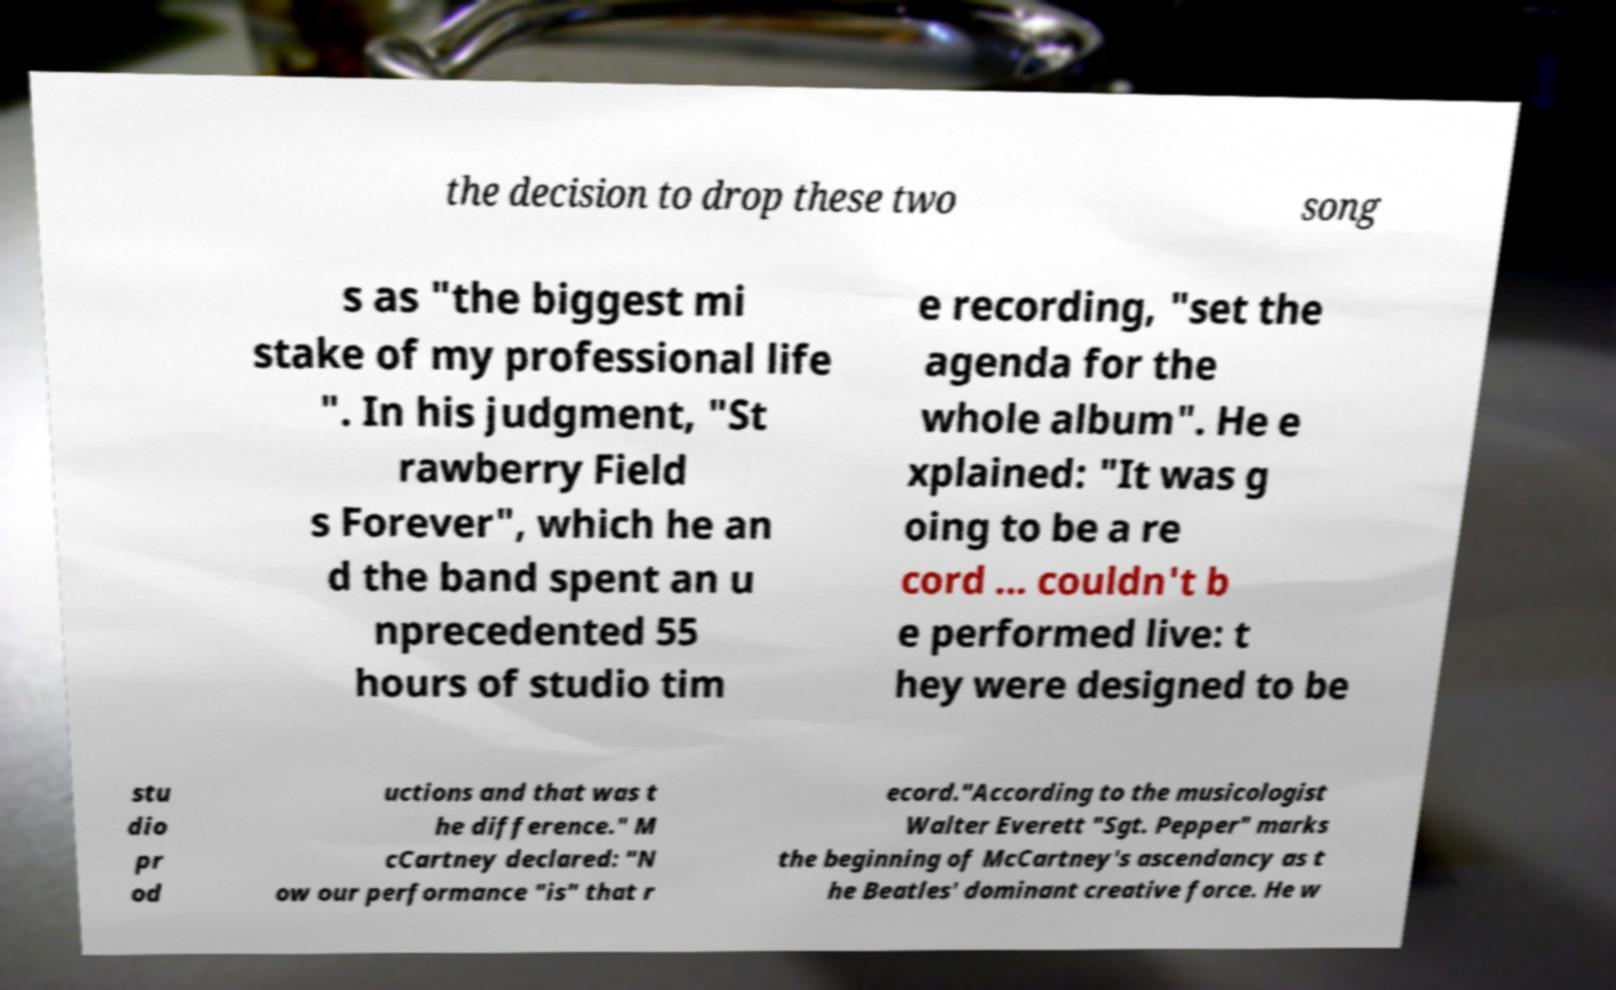I need the written content from this picture converted into text. Can you do that? the decision to drop these two song s as "the biggest mi stake of my professional life ". In his judgment, "St rawberry Field s Forever", which he an d the band spent an u nprecedented 55 hours of studio tim e recording, "set the agenda for the whole album". He e xplained: "It was g oing to be a re cord ... couldn't b e performed live: t hey were designed to be stu dio pr od uctions and that was t he difference." M cCartney declared: "N ow our performance "is" that r ecord."According to the musicologist Walter Everett "Sgt. Pepper" marks the beginning of McCartney's ascendancy as t he Beatles' dominant creative force. He w 